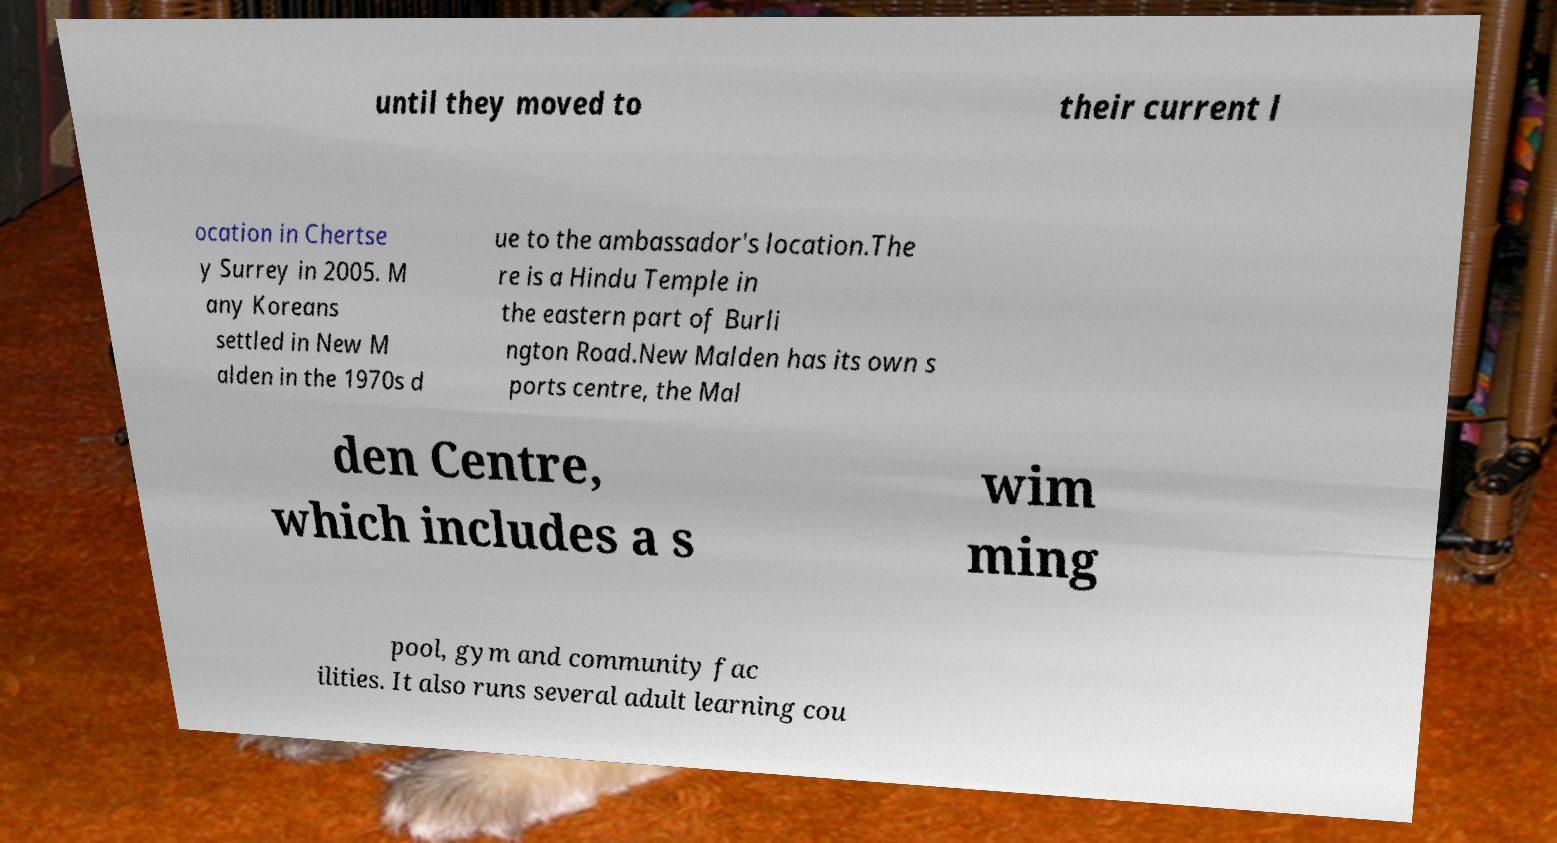Can you accurately transcribe the text from the provided image for me? until they moved to their current l ocation in Chertse y Surrey in 2005. M any Koreans settled in New M alden in the 1970s d ue to the ambassador's location.The re is a Hindu Temple in the eastern part of Burli ngton Road.New Malden has its own s ports centre, the Mal den Centre, which includes a s wim ming pool, gym and community fac ilities. It also runs several adult learning cou 